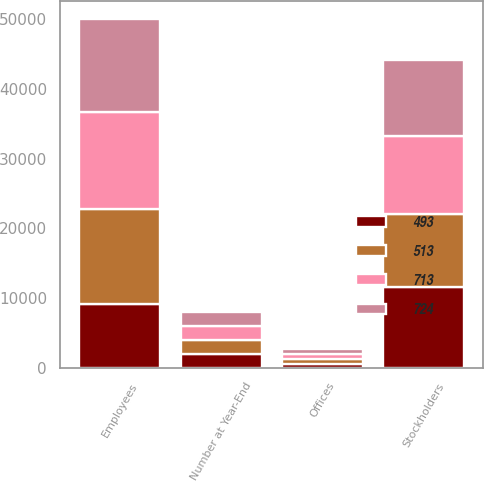<chart> <loc_0><loc_0><loc_500><loc_500><stacked_bar_chart><ecel><fcel>Number at Year-End<fcel>Stockholders<fcel>Employees<fcel>Offices<nl><fcel>513<fcel>2005<fcel>10437<fcel>13525<fcel>724<nl><fcel>724<fcel>2004<fcel>10857<fcel>13371<fcel>713<nl><fcel>713<fcel>2003<fcel>11258<fcel>14000<fcel>735<nl><fcel>493<fcel>2002<fcel>11587<fcel>9197<fcel>493<nl></chart> 